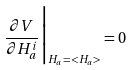<formula> <loc_0><loc_0><loc_500><loc_500>\frac { \partial V } { \partial H _ { a } ^ { i } } { \Big | } _ { H _ { a } = < H _ { a } > } = 0</formula> 